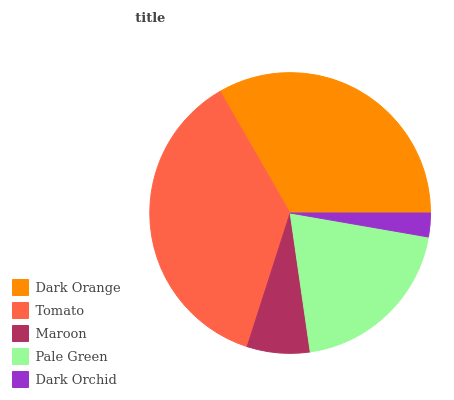Is Dark Orchid the minimum?
Answer yes or no. Yes. Is Tomato the maximum?
Answer yes or no. Yes. Is Maroon the minimum?
Answer yes or no. No. Is Maroon the maximum?
Answer yes or no. No. Is Tomato greater than Maroon?
Answer yes or no. Yes. Is Maroon less than Tomato?
Answer yes or no. Yes. Is Maroon greater than Tomato?
Answer yes or no. No. Is Tomato less than Maroon?
Answer yes or no. No. Is Pale Green the high median?
Answer yes or no. Yes. Is Pale Green the low median?
Answer yes or no. Yes. Is Dark Orchid the high median?
Answer yes or no. No. Is Maroon the low median?
Answer yes or no. No. 